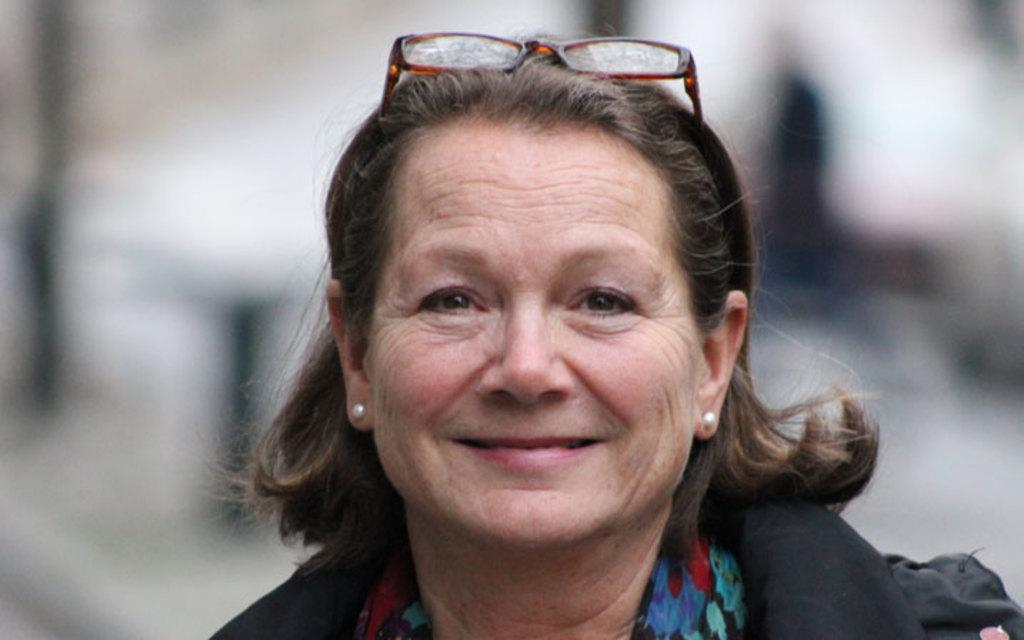Who is present in the image? There is a woman in the image. What expression does the woman have? The woman is smiling. Can you describe the background of the image? The background of the image is blurry. Reasoning: Let'g: Let's think step by step in order to produce the conversation. We start by identifying the main subject in the image, which is the woman. Then, we describe her expression, noting that she is smiling. Finally, we mention the background of the image, which is blurry. Each question is designed to elicit a specific detail about the image that is known from the provided facts. Absurd Question/Answer: What is the woman's brother doing in the image? There is no mention of a brother in the image, so it cannot be determined what the brother might be doing. What division is the woman participating in during the image? There is no indication of a division or any competitive event in the image, so it cannot be determined what division the woman might be participating in. 